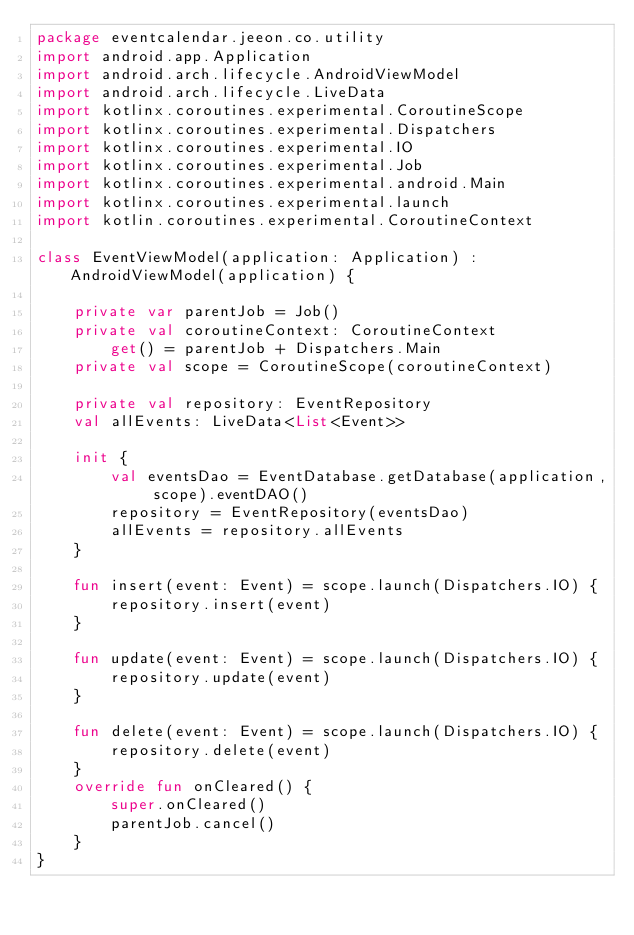<code> <loc_0><loc_0><loc_500><loc_500><_Kotlin_>package eventcalendar.jeeon.co.utility
import android.app.Application
import android.arch.lifecycle.AndroidViewModel
import android.arch.lifecycle.LiveData
import kotlinx.coroutines.experimental.CoroutineScope
import kotlinx.coroutines.experimental.Dispatchers
import kotlinx.coroutines.experimental.IO
import kotlinx.coroutines.experimental.Job
import kotlinx.coroutines.experimental.android.Main
import kotlinx.coroutines.experimental.launch
import kotlin.coroutines.experimental.CoroutineContext

class EventViewModel(application: Application) : AndroidViewModel(application) {

    private var parentJob = Job()
    private val coroutineContext: CoroutineContext
        get() = parentJob + Dispatchers.Main
    private val scope = CoroutineScope(coroutineContext)

    private val repository: EventRepository
    val allEvents: LiveData<List<Event>>

    init {
        val eventsDao = EventDatabase.getDatabase(application, scope).eventDAO()
        repository = EventRepository(eventsDao)
        allEvents = repository.allEvents
    }

    fun insert(event: Event) = scope.launch(Dispatchers.IO) {
        repository.insert(event)
    }

    fun update(event: Event) = scope.launch(Dispatchers.IO) {
        repository.update(event)
    }

    fun delete(event: Event) = scope.launch(Dispatchers.IO) {
        repository.delete(event)
    }
    override fun onCleared() {
        super.onCleared()
        parentJob.cancel()
    }
}</code> 